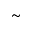Convert formula to latex. <formula><loc_0><loc_0><loc_500><loc_500>\sim</formula> 